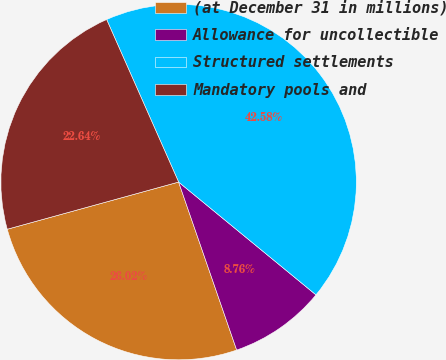Convert chart to OTSL. <chart><loc_0><loc_0><loc_500><loc_500><pie_chart><fcel>(at December 31 in millions)<fcel>Allowance for uncollectible<fcel>Structured settlements<fcel>Mandatory pools and<nl><fcel>26.02%<fcel>8.76%<fcel>42.58%<fcel>22.64%<nl></chart> 